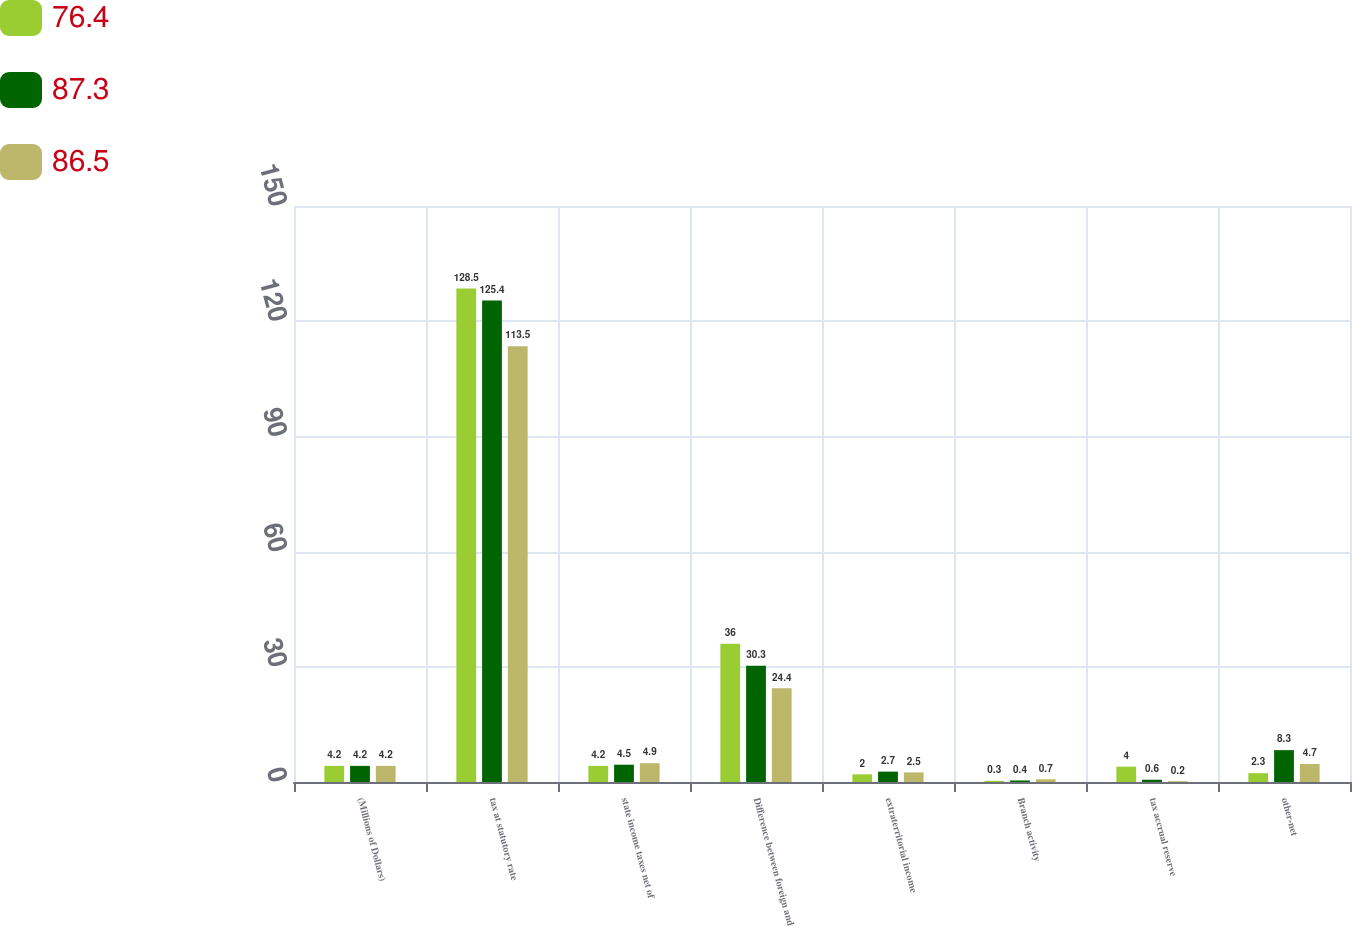<chart> <loc_0><loc_0><loc_500><loc_500><stacked_bar_chart><ecel><fcel>(Millions of Dollars)<fcel>tax at statutory rate<fcel>state income taxes net of<fcel>Difference between foreign and<fcel>extraterritorial income<fcel>Branch activity<fcel>tax accrual reserve<fcel>other-net<nl><fcel>76.4<fcel>4.2<fcel>128.5<fcel>4.2<fcel>36<fcel>2<fcel>0.3<fcel>4<fcel>2.3<nl><fcel>87.3<fcel>4.2<fcel>125.4<fcel>4.5<fcel>30.3<fcel>2.7<fcel>0.4<fcel>0.6<fcel>8.3<nl><fcel>86.5<fcel>4.2<fcel>113.5<fcel>4.9<fcel>24.4<fcel>2.5<fcel>0.7<fcel>0.2<fcel>4.7<nl></chart> 